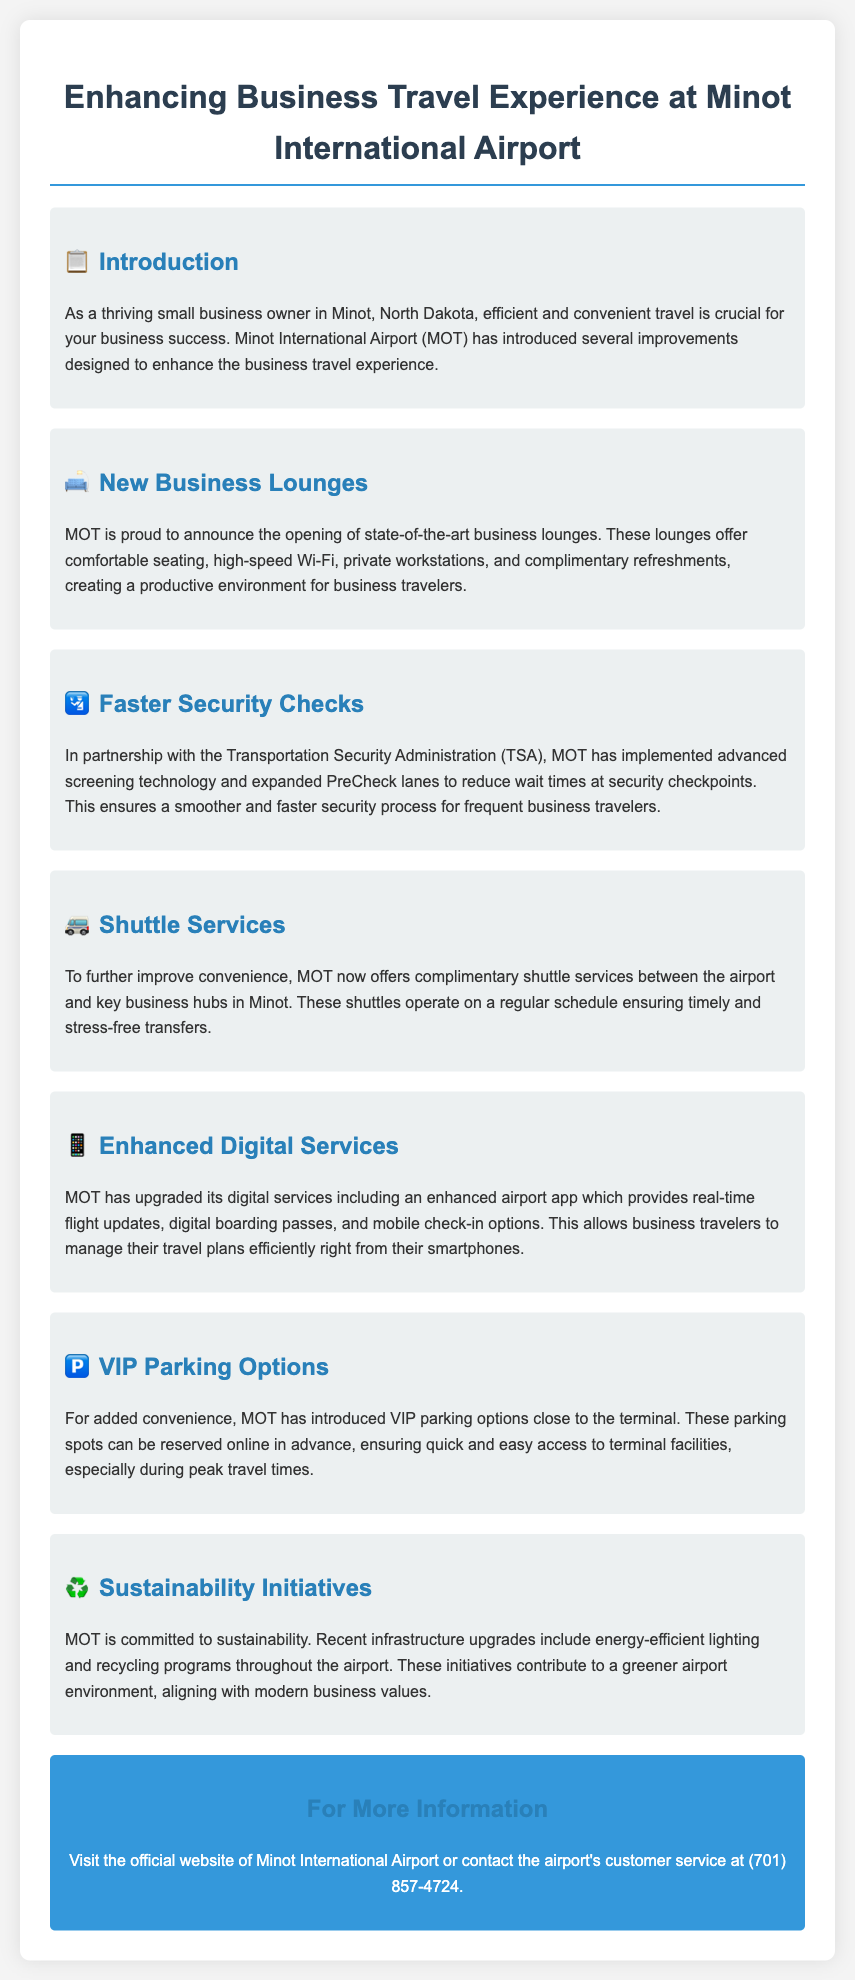What is the name of the airport discussed in the document? The document mentions Minot International Airport (MOT) as the subject of discussion.
Answer: Minot International Airport What new feature has been introduced for business travelers? The document highlights the opening of state-of-the-art business lounges as a new feature.
Answer: Business lounges Which organization did MOT partner with for faster security checks? The document states that MOT partnered with the Transportation Security Administration (TSA) for this improvement.
Answer: TSA What type of shuttle service is now offered by MOT? The document indicates that complimentary shuttle services are now available between the airport and key business hubs.
Answer: Complimentary What can be reserved online in advance at MOT? The document mentions that VIP parking options can be reserved online in advance.
Answer: VIP parking What is included in the new airport app's features? The enhanced airport app includes real-time flight updates, digital boarding passes, and mobile check-in options.
Answer: Real-time flight updates What sustainability initiative is mentioned in the document? The document refers to energy-efficient lighting as part of the sustainability initiatives at MOT.
Answer: Energy-efficient lighting How do the new business lounges benefit travelers? The document states that the lounges provide comfortable seating, high-speed Wi-Fi, private workstations, and complimentary refreshments for productivity.
Answer: Productive environment What is the purpose of the enhanced digital services? The document outlines that the enhanced services allow business travelers to manage their travel plans efficiently.
Answer: Manage travel plans efficiently 